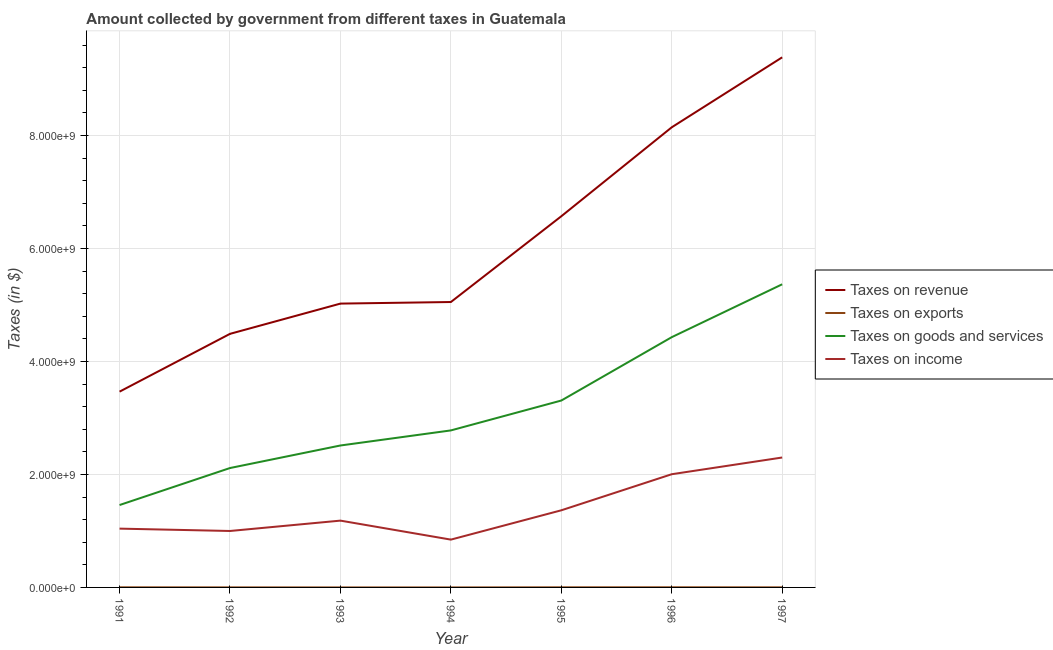Does the line corresponding to amount collected as tax on exports intersect with the line corresponding to amount collected as tax on revenue?
Make the answer very short. No. What is the amount collected as tax on goods in 1994?
Offer a terse response. 2.78e+09. Across all years, what is the maximum amount collected as tax on revenue?
Give a very brief answer. 9.38e+09. Across all years, what is the minimum amount collected as tax on revenue?
Give a very brief answer. 3.47e+09. What is the total amount collected as tax on revenue in the graph?
Keep it short and to the point. 4.21e+1. What is the difference between the amount collected as tax on income in 1991 and that in 1993?
Offer a very short reply. -1.42e+08. What is the difference between the amount collected as tax on income in 1997 and the amount collected as tax on exports in 1995?
Keep it short and to the point. 2.30e+09. What is the average amount collected as tax on revenue per year?
Provide a succinct answer. 6.02e+09. In the year 1997, what is the difference between the amount collected as tax on income and amount collected as tax on goods?
Your answer should be compact. -3.07e+09. In how many years, is the amount collected as tax on goods greater than 8000000000 $?
Offer a terse response. 0. What is the ratio of the amount collected as tax on income in 1993 to that in 1997?
Keep it short and to the point. 0.51. Is the amount collected as tax on goods in 1991 less than that in 1995?
Offer a very short reply. Yes. What is the difference between the highest and the second highest amount collected as tax on exports?
Your answer should be very brief. 6.90e+05. What is the difference between the highest and the lowest amount collected as tax on income?
Your answer should be very brief. 1.45e+09. Is the sum of the amount collected as tax on income in 1992 and 1997 greater than the maximum amount collected as tax on revenue across all years?
Offer a very short reply. No. Is the amount collected as tax on income strictly greater than the amount collected as tax on exports over the years?
Your answer should be very brief. Yes. Is the amount collected as tax on goods strictly less than the amount collected as tax on income over the years?
Make the answer very short. No. How many years are there in the graph?
Ensure brevity in your answer.  7. Are the values on the major ticks of Y-axis written in scientific E-notation?
Keep it short and to the point. Yes. Does the graph contain any zero values?
Provide a short and direct response. No. Does the graph contain grids?
Provide a succinct answer. Yes. How many legend labels are there?
Keep it short and to the point. 4. What is the title of the graph?
Offer a very short reply. Amount collected by government from different taxes in Guatemala. What is the label or title of the X-axis?
Provide a succinct answer. Year. What is the label or title of the Y-axis?
Keep it short and to the point. Taxes (in $). What is the Taxes (in $) in Taxes on revenue in 1991?
Offer a very short reply. 3.47e+09. What is the Taxes (in $) of Taxes on exports in 1991?
Your response must be concise. 1.92e+06. What is the Taxes (in $) in Taxes on goods and services in 1991?
Offer a terse response. 1.46e+09. What is the Taxes (in $) in Taxes on income in 1991?
Your answer should be compact. 1.04e+09. What is the Taxes (in $) of Taxes on revenue in 1992?
Your response must be concise. 4.49e+09. What is the Taxes (in $) of Taxes on exports in 1992?
Your answer should be very brief. 8.80e+05. What is the Taxes (in $) in Taxes on goods and services in 1992?
Provide a short and direct response. 2.11e+09. What is the Taxes (in $) in Taxes on income in 1992?
Your response must be concise. 9.99e+08. What is the Taxes (in $) of Taxes on revenue in 1993?
Offer a very short reply. 5.02e+09. What is the Taxes (in $) of Taxes on goods and services in 1993?
Your response must be concise. 2.51e+09. What is the Taxes (in $) in Taxes on income in 1993?
Your response must be concise. 1.18e+09. What is the Taxes (in $) in Taxes on revenue in 1994?
Ensure brevity in your answer.  5.05e+09. What is the Taxes (in $) of Taxes on goods and services in 1994?
Your answer should be compact. 2.78e+09. What is the Taxes (in $) of Taxes on income in 1994?
Offer a terse response. 8.46e+08. What is the Taxes (in $) in Taxes on revenue in 1995?
Provide a succinct answer. 6.57e+09. What is the Taxes (in $) in Taxes on exports in 1995?
Keep it short and to the point. 1.91e+06. What is the Taxes (in $) of Taxes on goods and services in 1995?
Keep it short and to the point. 3.31e+09. What is the Taxes (in $) in Taxes on income in 1995?
Offer a terse response. 1.37e+09. What is the Taxes (in $) in Taxes on revenue in 1996?
Keep it short and to the point. 8.14e+09. What is the Taxes (in $) of Taxes on exports in 1996?
Keep it short and to the point. 2.61e+06. What is the Taxes (in $) of Taxes on goods and services in 1996?
Your answer should be compact. 4.43e+09. What is the Taxes (in $) in Taxes on income in 1996?
Ensure brevity in your answer.  2.00e+09. What is the Taxes (in $) of Taxes on revenue in 1997?
Offer a terse response. 9.38e+09. What is the Taxes (in $) of Taxes on exports in 1997?
Offer a very short reply. 1.49e+06. What is the Taxes (in $) in Taxes on goods and services in 1997?
Ensure brevity in your answer.  5.37e+09. What is the Taxes (in $) in Taxes on income in 1997?
Ensure brevity in your answer.  2.30e+09. Across all years, what is the maximum Taxes (in $) of Taxes on revenue?
Your response must be concise. 9.38e+09. Across all years, what is the maximum Taxes (in $) in Taxes on exports?
Ensure brevity in your answer.  2.61e+06. Across all years, what is the maximum Taxes (in $) in Taxes on goods and services?
Provide a succinct answer. 5.37e+09. Across all years, what is the maximum Taxes (in $) in Taxes on income?
Ensure brevity in your answer.  2.30e+09. Across all years, what is the minimum Taxes (in $) of Taxes on revenue?
Offer a very short reply. 3.47e+09. Across all years, what is the minimum Taxes (in $) in Taxes on goods and services?
Ensure brevity in your answer.  1.46e+09. Across all years, what is the minimum Taxes (in $) of Taxes on income?
Provide a short and direct response. 8.46e+08. What is the total Taxes (in $) of Taxes on revenue in the graph?
Offer a very short reply. 4.21e+1. What is the total Taxes (in $) of Taxes on exports in the graph?
Your response must be concise. 8.83e+06. What is the total Taxes (in $) of Taxes on goods and services in the graph?
Your answer should be compact. 2.20e+1. What is the total Taxes (in $) of Taxes on income in the graph?
Offer a very short reply. 9.74e+09. What is the difference between the Taxes (in $) in Taxes on revenue in 1991 and that in 1992?
Offer a terse response. -1.02e+09. What is the difference between the Taxes (in $) in Taxes on exports in 1991 and that in 1992?
Your response must be concise. 1.04e+06. What is the difference between the Taxes (in $) in Taxes on goods and services in 1991 and that in 1992?
Offer a terse response. -6.55e+08. What is the difference between the Taxes (in $) of Taxes on income in 1991 and that in 1992?
Offer a very short reply. 4.18e+07. What is the difference between the Taxes (in $) of Taxes on revenue in 1991 and that in 1993?
Your answer should be very brief. -1.56e+09. What is the difference between the Taxes (in $) in Taxes on exports in 1991 and that in 1993?
Make the answer very short. 1.91e+06. What is the difference between the Taxes (in $) in Taxes on goods and services in 1991 and that in 1993?
Keep it short and to the point. -1.05e+09. What is the difference between the Taxes (in $) of Taxes on income in 1991 and that in 1993?
Make the answer very short. -1.42e+08. What is the difference between the Taxes (in $) of Taxes on revenue in 1991 and that in 1994?
Your answer should be compact. -1.59e+09. What is the difference between the Taxes (in $) in Taxes on exports in 1991 and that in 1994?
Provide a succinct answer. 1.91e+06. What is the difference between the Taxes (in $) of Taxes on goods and services in 1991 and that in 1994?
Keep it short and to the point. -1.32e+09. What is the difference between the Taxes (in $) of Taxes on income in 1991 and that in 1994?
Make the answer very short. 1.95e+08. What is the difference between the Taxes (in $) of Taxes on revenue in 1991 and that in 1995?
Your response must be concise. -3.10e+09. What is the difference between the Taxes (in $) in Taxes on goods and services in 1991 and that in 1995?
Your response must be concise. -1.85e+09. What is the difference between the Taxes (in $) of Taxes on income in 1991 and that in 1995?
Ensure brevity in your answer.  -3.24e+08. What is the difference between the Taxes (in $) in Taxes on revenue in 1991 and that in 1996?
Offer a terse response. -4.68e+09. What is the difference between the Taxes (in $) in Taxes on exports in 1991 and that in 1996?
Make the answer very short. -6.90e+05. What is the difference between the Taxes (in $) in Taxes on goods and services in 1991 and that in 1996?
Give a very brief answer. -2.97e+09. What is the difference between the Taxes (in $) of Taxes on income in 1991 and that in 1996?
Offer a very short reply. -9.63e+08. What is the difference between the Taxes (in $) in Taxes on revenue in 1991 and that in 1997?
Offer a terse response. -5.92e+09. What is the difference between the Taxes (in $) in Taxes on exports in 1991 and that in 1997?
Your answer should be compact. 4.30e+05. What is the difference between the Taxes (in $) of Taxes on goods and services in 1991 and that in 1997?
Offer a terse response. -3.91e+09. What is the difference between the Taxes (in $) in Taxes on income in 1991 and that in 1997?
Provide a succinct answer. -1.26e+09. What is the difference between the Taxes (in $) in Taxes on revenue in 1992 and that in 1993?
Your answer should be compact. -5.35e+08. What is the difference between the Taxes (in $) of Taxes on exports in 1992 and that in 1993?
Your response must be concise. 8.70e+05. What is the difference between the Taxes (in $) in Taxes on goods and services in 1992 and that in 1993?
Make the answer very short. -3.99e+08. What is the difference between the Taxes (in $) of Taxes on income in 1992 and that in 1993?
Keep it short and to the point. -1.83e+08. What is the difference between the Taxes (in $) of Taxes on revenue in 1992 and that in 1994?
Your answer should be very brief. -5.63e+08. What is the difference between the Taxes (in $) of Taxes on exports in 1992 and that in 1994?
Ensure brevity in your answer.  8.70e+05. What is the difference between the Taxes (in $) of Taxes on goods and services in 1992 and that in 1994?
Provide a short and direct response. -6.66e+08. What is the difference between the Taxes (in $) in Taxes on income in 1992 and that in 1994?
Offer a terse response. 1.53e+08. What is the difference between the Taxes (in $) in Taxes on revenue in 1992 and that in 1995?
Your answer should be compact. -2.08e+09. What is the difference between the Taxes (in $) of Taxes on exports in 1992 and that in 1995?
Your answer should be compact. -1.03e+06. What is the difference between the Taxes (in $) of Taxes on goods and services in 1992 and that in 1995?
Your answer should be very brief. -1.19e+09. What is the difference between the Taxes (in $) in Taxes on income in 1992 and that in 1995?
Your answer should be very brief. -3.66e+08. What is the difference between the Taxes (in $) of Taxes on revenue in 1992 and that in 1996?
Your answer should be very brief. -3.66e+09. What is the difference between the Taxes (in $) in Taxes on exports in 1992 and that in 1996?
Provide a succinct answer. -1.73e+06. What is the difference between the Taxes (in $) of Taxes on goods and services in 1992 and that in 1996?
Offer a terse response. -2.32e+09. What is the difference between the Taxes (in $) of Taxes on income in 1992 and that in 1996?
Provide a succinct answer. -1.00e+09. What is the difference between the Taxes (in $) of Taxes on revenue in 1992 and that in 1997?
Your response must be concise. -4.89e+09. What is the difference between the Taxes (in $) of Taxes on exports in 1992 and that in 1997?
Keep it short and to the point. -6.10e+05. What is the difference between the Taxes (in $) in Taxes on goods and services in 1992 and that in 1997?
Provide a succinct answer. -3.25e+09. What is the difference between the Taxes (in $) in Taxes on income in 1992 and that in 1997?
Make the answer very short. -1.30e+09. What is the difference between the Taxes (in $) in Taxes on revenue in 1993 and that in 1994?
Provide a short and direct response. -2.78e+07. What is the difference between the Taxes (in $) in Taxes on goods and services in 1993 and that in 1994?
Your answer should be compact. -2.67e+08. What is the difference between the Taxes (in $) in Taxes on income in 1993 and that in 1994?
Give a very brief answer. 3.36e+08. What is the difference between the Taxes (in $) of Taxes on revenue in 1993 and that in 1995?
Ensure brevity in your answer.  -1.55e+09. What is the difference between the Taxes (in $) in Taxes on exports in 1993 and that in 1995?
Provide a short and direct response. -1.90e+06. What is the difference between the Taxes (in $) in Taxes on goods and services in 1993 and that in 1995?
Make the answer very short. -7.96e+08. What is the difference between the Taxes (in $) in Taxes on income in 1993 and that in 1995?
Your answer should be very brief. -1.83e+08. What is the difference between the Taxes (in $) in Taxes on revenue in 1993 and that in 1996?
Your response must be concise. -3.12e+09. What is the difference between the Taxes (in $) in Taxes on exports in 1993 and that in 1996?
Your answer should be compact. -2.60e+06. What is the difference between the Taxes (in $) of Taxes on goods and services in 1993 and that in 1996?
Provide a succinct answer. -1.92e+09. What is the difference between the Taxes (in $) of Taxes on income in 1993 and that in 1996?
Provide a short and direct response. -8.21e+08. What is the difference between the Taxes (in $) of Taxes on revenue in 1993 and that in 1997?
Provide a short and direct response. -4.36e+09. What is the difference between the Taxes (in $) of Taxes on exports in 1993 and that in 1997?
Keep it short and to the point. -1.48e+06. What is the difference between the Taxes (in $) of Taxes on goods and services in 1993 and that in 1997?
Provide a succinct answer. -2.85e+09. What is the difference between the Taxes (in $) of Taxes on income in 1993 and that in 1997?
Keep it short and to the point. -1.12e+09. What is the difference between the Taxes (in $) in Taxes on revenue in 1994 and that in 1995?
Give a very brief answer. -1.52e+09. What is the difference between the Taxes (in $) of Taxes on exports in 1994 and that in 1995?
Provide a short and direct response. -1.90e+06. What is the difference between the Taxes (in $) of Taxes on goods and services in 1994 and that in 1995?
Your answer should be compact. -5.29e+08. What is the difference between the Taxes (in $) of Taxes on income in 1994 and that in 1995?
Your answer should be very brief. -5.19e+08. What is the difference between the Taxes (in $) in Taxes on revenue in 1994 and that in 1996?
Make the answer very short. -3.09e+09. What is the difference between the Taxes (in $) in Taxes on exports in 1994 and that in 1996?
Provide a short and direct response. -2.60e+06. What is the difference between the Taxes (in $) in Taxes on goods and services in 1994 and that in 1996?
Your answer should be very brief. -1.65e+09. What is the difference between the Taxes (in $) in Taxes on income in 1994 and that in 1996?
Provide a short and direct response. -1.16e+09. What is the difference between the Taxes (in $) of Taxes on revenue in 1994 and that in 1997?
Offer a very short reply. -4.33e+09. What is the difference between the Taxes (in $) of Taxes on exports in 1994 and that in 1997?
Your answer should be compact. -1.48e+06. What is the difference between the Taxes (in $) of Taxes on goods and services in 1994 and that in 1997?
Offer a very short reply. -2.59e+09. What is the difference between the Taxes (in $) in Taxes on income in 1994 and that in 1997?
Keep it short and to the point. -1.45e+09. What is the difference between the Taxes (in $) of Taxes on revenue in 1995 and that in 1996?
Ensure brevity in your answer.  -1.57e+09. What is the difference between the Taxes (in $) in Taxes on exports in 1995 and that in 1996?
Ensure brevity in your answer.  -7.00e+05. What is the difference between the Taxes (in $) of Taxes on goods and services in 1995 and that in 1996?
Offer a very short reply. -1.12e+09. What is the difference between the Taxes (in $) in Taxes on income in 1995 and that in 1996?
Your answer should be very brief. -6.39e+08. What is the difference between the Taxes (in $) of Taxes on revenue in 1995 and that in 1997?
Your response must be concise. -2.81e+09. What is the difference between the Taxes (in $) of Taxes on exports in 1995 and that in 1997?
Give a very brief answer. 4.20e+05. What is the difference between the Taxes (in $) of Taxes on goods and services in 1995 and that in 1997?
Your response must be concise. -2.06e+09. What is the difference between the Taxes (in $) of Taxes on income in 1995 and that in 1997?
Offer a terse response. -9.34e+08. What is the difference between the Taxes (in $) in Taxes on revenue in 1996 and that in 1997?
Provide a succinct answer. -1.24e+09. What is the difference between the Taxes (in $) of Taxes on exports in 1996 and that in 1997?
Offer a very short reply. 1.12e+06. What is the difference between the Taxes (in $) in Taxes on goods and services in 1996 and that in 1997?
Offer a very short reply. -9.36e+08. What is the difference between the Taxes (in $) of Taxes on income in 1996 and that in 1997?
Your answer should be compact. -2.96e+08. What is the difference between the Taxes (in $) of Taxes on revenue in 1991 and the Taxes (in $) of Taxes on exports in 1992?
Keep it short and to the point. 3.46e+09. What is the difference between the Taxes (in $) of Taxes on revenue in 1991 and the Taxes (in $) of Taxes on goods and services in 1992?
Offer a very short reply. 1.35e+09. What is the difference between the Taxes (in $) of Taxes on revenue in 1991 and the Taxes (in $) of Taxes on income in 1992?
Provide a succinct answer. 2.47e+09. What is the difference between the Taxes (in $) of Taxes on exports in 1991 and the Taxes (in $) of Taxes on goods and services in 1992?
Ensure brevity in your answer.  -2.11e+09. What is the difference between the Taxes (in $) of Taxes on exports in 1991 and the Taxes (in $) of Taxes on income in 1992?
Your response must be concise. -9.97e+08. What is the difference between the Taxes (in $) of Taxes on goods and services in 1991 and the Taxes (in $) of Taxes on income in 1992?
Keep it short and to the point. 4.59e+08. What is the difference between the Taxes (in $) in Taxes on revenue in 1991 and the Taxes (in $) in Taxes on exports in 1993?
Keep it short and to the point. 3.47e+09. What is the difference between the Taxes (in $) in Taxes on revenue in 1991 and the Taxes (in $) in Taxes on goods and services in 1993?
Keep it short and to the point. 9.53e+08. What is the difference between the Taxes (in $) in Taxes on revenue in 1991 and the Taxes (in $) in Taxes on income in 1993?
Your response must be concise. 2.28e+09. What is the difference between the Taxes (in $) of Taxes on exports in 1991 and the Taxes (in $) of Taxes on goods and services in 1993?
Your answer should be compact. -2.51e+09. What is the difference between the Taxes (in $) in Taxes on exports in 1991 and the Taxes (in $) in Taxes on income in 1993?
Offer a very short reply. -1.18e+09. What is the difference between the Taxes (in $) in Taxes on goods and services in 1991 and the Taxes (in $) in Taxes on income in 1993?
Your answer should be very brief. 2.76e+08. What is the difference between the Taxes (in $) of Taxes on revenue in 1991 and the Taxes (in $) of Taxes on exports in 1994?
Your answer should be compact. 3.47e+09. What is the difference between the Taxes (in $) of Taxes on revenue in 1991 and the Taxes (in $) of Taxes on goods and services in 1994?
Your answer should be very brief. 6.86e+08. What is the difference between the Taxes (in $) of Taxes on revenue in 1991 and the Taxes (in $) of Taxes on income in 1994?
Offer a terse response. 2.62e+09. What is the difference between the Taxes (in $) in Taxes on exports in 1991 and the Taxes (in $) in Taxes on goods and services in 1994?
Provide a succinct answer. -2.78e+09. What is the difference between the Taxes (in $) of Taxes on exports in 1991 and the Taxes (in $) of Taxes on income in 1994?
Keep it short and to the point. -8.44e+08. What is the difference between the Taxes (in $) in Taxes on goods and services in 1991 and the Taxes (in $) in Taxes on income in 1994?
Your answer should be compact. 6.12e+08. What is the difference between the Taxes (in $) of Taxes on revenue in 1991 and the Taxes (in $) of Taxes on exports in 1995?
Provide a succinct answer. 3.46e+09. What is the difference between the Taxes (in $) of Taxes on revenue in 1991 and the Taxes (in $) of Taxes on goods and services in 1995?
Keep it short and to the point. 1.57e+08. What is the difference between the Taxes (in $) of Taxes on revenue in 1991 and the Taxes (in $) of Taxes on income in 1995?
Your response must be concise. 2.10e+09. What is the difference between the Taxes (in $) in Taxes on exports in 1991 and the Taxes (in $) in Taxes on goods and services in 1995?
Give a very brief answer. -3.31e+09. What is the difference between the Taxes (in $) of Taxes on exports in 1991 and the Taxes (in $) of Taxes on income in 1995?
Your answer should be very brief. -1.36e+09. What is the difference between the Taxes (in $) of Taxes on goods and services in 1991 and the Taxes (in $) of Taxes on income in 1995?
Ensure brevity in your answer.  9.32e+07. What is the difference between the Taxes (in $) in Taxes on revenue in 1991 and the Taxes (in $) in Taxes on exports in 1996?
Provide a short and direct response. 3.46e+09. What is the difference between the Taxes (in $) of Taxes on revenue in 1991 and the Taxes (in $) of Taxes on goods and services in 1996?
Your answer should be compact. -9.64e+08. What is the difference between the Taxes (in $) of Taxes on revenue in 1991 and the Taxes (in $) of Taxes on income in 1996?
Offer a very short reply. 1.46e+09. What is the difference between the Taxes (in $) in Taxes on exports in 1991 and the Taxes (in $) in Taxes on goods and services in 1996?
Ensure brevity in your answer.  -4.43e+09. What is the difference between the Taxes (in $) of Taxes on exports in 1991 and the Taxes (in $) of Taxes on income in 1996?
Ensure brevity in your answer.  -2.00e+09. What is the difference between the Taxes (in $) of Taxes on goods and services in 1991 and the Taxes (in $) of Taxes on income in 1996?
Make the answer very short. -5.45e+08. What is the difference between the Taxes (in $) of Taxes on revenue in 1991 and the Taxes (in $) of Taxes on exports in 1997?
Offer a very short reply. 3.46e+09. What is the difference between the Taxes (in $) of Taxes on revenue in 1991 and the Taxes (in $) of Taxes on goods and services in 1997?
Provide a succinct answer. -1.90e+09. What is the difference between the Taxes (in $) of Taxes on revenue in 1991 and the Taxes (in $) of Taxes on income in 1997?
Provide a short and direct response. 1.17e+09. What is the difference between the Taxes (in $) of Taxes on exports in 1991 and the Taxes (in $) of Taxes on goods and services in 1997?
Ensure brevity in your answer.  -5.36e+09. What is the difference between the Taxes (in $) of Taxes on exports in 1991 and the Taxes (in $) of Taxes on income in 1997?
Offer a very short reply. -2.30e+09. What is the difference between the Taxes (in $) in Taxes on goods and services in 1991 and the Taxes (in $) in Taxes on income in 1997?
Ensure brevity in your answer.  -8.41e+08. What is the difference between the Taxes (in $) of Taxes on revenue in 1992 and the Taxes (in $) of Taxes on exports in 1993?
Offer a very short reply. 4.49e+09. What is the difference between the Taxes (in $) in Taxes on revenue in 1992 and the Taxes (in $) in Taxes on goods and services in 1993?
Offer a very short reply. 1.98e+09. What is the difference between the Taxes (in $) in Taxes on revenue in 1992 and the Taxes (in $) in Taxes on income in 1993?
Provide a succinct answer. 3.31e+09. What is the difference between the Taxes (in $) in Taxes on exports in 1992 and the Taxes (in $) in Taxes on goods and services in 1993?
Keep it short and to the point. -2.51e+09. What is the difference between the Taxes (in $) of Taxes on exports in 1992 and the Taxes (in $) of Taxes on income in 1993?
Make the answer very short. -1.18e+09. What is the difference between the Taxes (in $) of Taxes on goods and services in 1992 and the Taxes (in $) of Taxes on income in 1993?
Give a very brief answer. 9.31e+08. What is the difference between the Taxes (in $) of Taxes on revenue in 1992 and the Taxes (in $) of Taxes on exports in 1994?
Ensure brevity in your answer.  4.49e+09. What is the difference between the Taxes (in $) of Taxes on revenue in 1992 and the Taxes (in $) of Taxes on goods and services in 1994?
Give a very brief answer. 1.71e+09. What is the difference between the Taxes (in $) of Taxes on revenue in 1992 and the Taxes (in $) of Taxes on income in 1994?
Your answer should be very brief. 3.64e+09. What is the difference between the Taxes (in $) in Taxes on exports in 1992 and the Taxes (in $) in Taxes on goods and services in 1994?
Keep it short and to the point. -2.78e+09. What is the difference between the Taxes (in $) of Taxes on exports in 1992 and the Taxes (in $) of Taxes on income in 1994?
Provide a succinct answer. -8.45e+08. What is the difference between the Taxes (in $) of Taxes on goods and services in 1992 and the Taxes (in $) of Taxes on income in 1994?
Offer a terse response. 1.27e+09. What is the difference between the Taxes (in $) of Taxes on revenue in 1992 and the Taxes (in $) of Taxes on exports in 1995?
Your answer should be compact. 4.49e+09. What is the difference between the Taxes (in $) of Taxes on revenue in 1992 and the Taxes (in $) of Taxes on goods and services in 1995?
Keep it short and to the point. 1.18e+09. What is the difference between the Taxes (in $) of Taxes on revenue in 1992 and the Taxes (in $) of Taxes on income in 1995?
Your answer should be compact. 3.12e+09. What is the difference between the Taxes (in $) in Taxes on exports in 1992 and the Taxes (in $) in Taxes on goods and services in 1995?
Give a very brief answer. -3.31e+09. What is the difference between the Taxes (in $) in Taxes on exports in 1992 and the Taxes (in $) in Taxes on income in 1995?
Offer a very short reply. -1.36e+09. What is the difference between the Taxes (in $) in Taxes on goods and services in 1992 and the Taxes (in $) in Taxes on income in 1995?
Provide a short and direct response. 7.48e+08. What is the difference between the Taxes (in $) in Taxes on revenue in 1992 and the Taxes (in $) in Taxes on exports in 1996?
Provide a succinct answer. 4.49e+09. What is the difference between the Taxes (in $) in Taxes on revenue in 1992 and the Taxes (in $) in Taxes on goods and services in 1996?
Provide a succinct answer. 5.88e+07. What is the difference between the Taxes (in $) of Taxes on revenue in 1992 and the Taxes (in $) of Taxes on income in 1996?
Offer a terse response. 2.48e+09. What is the difference between the Taxes (in $) in Taxes on exports in 1992 and the Taxes (in $) in Taxes on goods and services in 1996?
Provide a short and direct response. -4.43e+09. What is the difference between the Taxes (in $) of Taxes on exports in 1992 and the Taxes (in $) of Taxes on income in 1996?
Make the answer very short. -2.00e+09. What is the difference between the Taxes (in $) in Taxes on goods and services in 1992 and the Taxes (in $) in Taxes on income in 1996?
Provide a short and direct response. 1.10e+08. What is the difference between the Taxes (in $) of Taxes on revenue in 1992 and the Taxes (in $) of Taxes on exports in 1997?
Offer a very short reply. 4.49e+09. What is the difference between the Taxes (in $) of Taxes on revenue in 1992 and the Taxes (in $) of Taxes on goods and services in 1997?
Keep it short and to the point. -8.77e+08. What is the difference between the Taxes (in $) of Taxes on revenue in 1992 and the Taxes (in $) of Taxes on income in 1997?
Offer a terse response. 2.19e+09. What is the difference between the Taxes (in $) of Taxes on exports in 1992 and the Taxes (in $) of Taxes on goods and services in 1997?
Offer a terse response. -5.36e+09. What is the difference between the Taxes (in $) in Taxes on exports in 1992 and the Taxes (in $) in Taxes on income in 1997?
Your answer should be compact. -2.30e+09. What is the difference between the Taxes (in $) in Taxes on goods and services in 1992 and the Taxes (in $) in Taxes on income in 1997?
Offer a terse response. -1.86e+08. What is the difference between the Taxes (in $) in Taxes on revenue in 1993 and the Taxes (in $) in Taxes on exports in 1994?
Your answer should be compact. 5.02e+09. What is the difference between the Taxes (in $) in Taxes on revenue in 1993 and the Taxes (in $) in Taxes on goods and services in 1994?
Your response must be concise. 2.24e+09. What is the difference between the Taxes (in $) of Taxes on revenue in 1993 and the Taxes (in $) of Taxes on income in 1994?
Keep it short and to the point. 4.18e+09. What is the difference between the Taxes (in $) in Taxes on exports in 1993 and the Taxes (in $) in Taxes on goods and services in 1994?
Make the answer very short. -2.78e+09. What is the difference between the Taxes (in $) of Taxes on exports in 1993 and the Taxes (in $) of Taxes on income in 1994?
Provide a short and direct response. -8.46e+08. What is the difference between the Taxes (in $) of Taxes on goods and services in 1993 and the Taxes (in $) of Taxes on income in 1994?
Offer a very short reply. 1.67e+09. What is the difference between the Taxes (in $) of Taxes on revenue in 1993 and the Taxes (in $) of Taxes on exports in 1995?
Offer a terse response. 5.02e+09. What is the difference between the Taxes (in $) of Taxes on revenue in 1993 and the Taxes (in $) of Taxes on goods and services in 1995?
Offer a terse response. 1.72e+09. What is the difference between the Taxes (in $) of Taxes on revenue in 1993 and the Taxes (in $) of Taxes on income in 1995?
Give a very brief answer. 3.66e+09. What is the difference between the Taxes (in $) of Taxes on exports in 1993 and the Taxes (in $) of Taxes on goods and services in 1995?
Provide a succinct answer. -3.31e+09. What is the difference between the Taxes (in $) in Taxes on exports in 1993 and the Taxes (in $) in Taxes on income in 1995?
Offer a very short reply. -1.37e+09. What is the difference between the Taxes (in $) of Taxes on goods and services in 1993 and the Taxes (in $) of Taxes on income in 1995?
Ensure brevity in your answer.  1.15e+09. What is the difference between the Taxes (in $) of Taxes on revenue in 1993 and the Taxes (in $) of Taxes on exports in 1996?
Provide a succinct answer. 5.02e+09. What is the difference between the Taxes (in $) in Taxes on revenue in 1993 and the Taxes (in $) in Taxes on goods and services in 1996?
Provide a succinct answer. 5.94e+08. What is the difference between the Taxes (in $) in Taxes on revenue in 1993 and the Taxes (in $) in Taxes on income in 1996?
Provide a succinct answer. 3.02e+09. What is the difference between the Taxes (in $) in Taxes on exports in 1993 and the Taxes (in $) in Taxes on goods and services in 1996?
Your answer should be compact. -4.43e+09. What is the difference between the Taxes (in $) in Taxes on exports in 1993 and the Taxes (in $) in Taxes on income in 1996?
Make the answer very short. -2.00e+09. What is the difference between the Taxes (in $) of Taxes on goods and services in 1993 and the Taxes (in $) of Taxes on income in 1996?
Ensure brevity in your answer.  5.09e+08. What is the difference between the Taxes (in $) in Taxes on revenue in 1993 and the Taxes (in $) in Taxes on exports in 1997?
Provide a succinct answer. 5.02e+09. What is the difference between the Taxes (in $) in Taxes on revenue in 1993 and the Taxes (in $) in Taxes on goods and services in 1997?
Provide a succinct answer. -3.42e+08. What is the difference between the Taxes (in $) of Taxes on revenue in 1993 and the Taxes (in $) of Taxes on income in 1997?
Offer a terse response. 2.72e+09. What is the difference between the Taxes (in $) in Taxes on exports in 1993 and the Taxes (in $) in Taxes on goods and services in 1997?
Make the answer very short. -5.37e+09. What is the difference between the Taxes (in $) of Taxes on exports in 1993 and the Taxes (in $) of Taxes on income in 1997?
Offer a terse response. -2.30e+09. What is the difference between the Taxes (in $) of Taxes on goods and services in 1993 and the Taxes (in $) of Taxes on income in 1997?
Ensure brevity in your answer.  2.13e+08. What is the difference between the Taxes (in $) in Taxes on revenue in 1994 and the Taxes (in $) in Taxes on exports in 1995?
Offer a very short reply. 5.05e+09. What is the difference between the Taxes (in $) in Taxes on revenue in 1994 and the Taxes (in $) in Taxes on goods and services in 1995?
Your response must be concise. 1.74e+09. What is the difference between the Taxes (in $) in Taxes on revenue in 1994 and the Taxes (in $) in Taxes on income in 1995?
Your answer should be very brief. 3.69e+09. What is the difference between the Taxes (in $) of Taxes on exports in 1994 and the Taxes (in $) of Taxes on goods and services in 1995?
Ensure brevity in your answer.  -3.31e+09. What is the difference between the Taxes (in $) in Taxes on exports in 1994 and the Taxes (in $) in Taxes on income in 1995?
Ensure brevity in your answer.  -1.37e+09. What is the difference between the Taxes (in $) of Taxes on goods and services in 1994 and the Taxes (in $) of Taxes on income in 1995?
Your answer should be very brief. 1.41e+09. What is the difference between the Taxes (in $) of Taxes on revenue in 1994 and the Taxes (in $) of Taxes on exports in 1996?
Your answer should be compact. 5.05e+09. What is the difference between the Taxes (in $) of Taxes on revenue in 1994 and the Taxes (in $) of Taxes on goods and services in 1996?
Provide a succinct answer. 6.22e+08. What is the difference between the Taxes (in $) of Taxes on revenue in 1994 and the Taxes (in $) of Taxes on income in 1996?
Provide a short and direct response. 3.05e+09. What is the difference between the Taxes (in $) of Taxes on exports in 1994 and the Taxes (in $) of Taxes on goods and services in 1996?
Provide a succinct answer. -4.43e+09. What is the difference between the Taxes (in $) of Taxes on exports in 1994 and the Taxes (in $) of Taxes on income in 1996?
Make the answer very short. -2.00e+09. What is the difference between the Taxes (in $) of Taxes on goods and services in 1994 and the Taxes (in $) of Taxes on income in 1996?
Give a very brief answer. 7.75e+08. What is the difference between the Taxes (in $) in Taxes on revenue in 1994 and the Taxes (in $) in Taxes on exports in 1997?
Ensure brevity in your answer.  5.05e+09. What is the difference between the Taxes (in $) in Taxes on revenue in 1994 and the Taxes (in $) in Taxes on goods and services in 1997?
Your answer should be very brief. -3.14e+08. What is the difference between the Taxes (in $) of Taxes on revenue in 1994 and the Taxes (in $) of Taxes on income in 1997?
Offer a very short reply. 2.75e+09. What is the difference between the Taxes (in $) of Taxes on exports in 1994 and the Taxes (in $) of Taxes on goods and services in 1997?
Offer a very short reply. -5.37e+09. What is the difference between the Taxes (in $) in Taxes on exports in 1994 and the Taxes (in $) in Taxes on income in 1997?
Offer a terse response. -2.30e+09. What is the difference between the Taxes (in $) in Taxes on goods and services in 1994 and the Taxes (in $) in Taxes on income in 1997?
Your answer should be compact. 4.79e+08. What is the difference between the Taxes (in $) of Taxes on revenue in 1995 and the Taxes (in $) of Taxes on exports in 1996?
Your response must be concise. 6.57e+09. What is the difference between the Taxes (in $) of Taxes on revenue in 1995 and the Taxes (in $) of Taxes on goods and services in 1996?
Provide a succinct answer. 2.14e+09. What is the difference between the Taxes (in $) of Taxes on revenue in 1995 and the Taxes (in $) of Taxes on income in 1996?
Offer a very short reply. 4.57e+09. What is the difference between the Taxes (in $) of Taxes on exports in 1995 and the Taxes (in $) of Taxes on goods and services in 1996?
Your answer should be very brief. -4.43e+09. What is the difference between the Taxes (in $) in Taxes on exports in 1995 and the Taxes (in $) in Taxes on income in 1996?
Your response must be concise. -2.00e+09. What is the difference between the Taxes (in $) of Taxes on goods and services in 1995 and the Taxes (in $) of Taxes on income in 1996?
Your answer should be compact. 1.30e+09. What is the difference between the Taxes (in $) in Taxes on revenue in 1995 and the Taxes (in $) in Taxes on exports in 1997?
Offer a very short reply. 6.57e+09. What is the difference between the Taxes (in $) of Taxes on revenue in 1995 and the Taxes (in $) of Taxes on goods and services in 1997?
Your answer should be very brief. 1.20e+09. What is the difference between the Taxes (in $) of Taxes on revenue in 1995 and the Taxes (in $) of Taxes on income in 1997?
Provide a succinct answer. 4.27e+09. What is the difference between the Taxes (in $) in Taxes on exports in 1995 and the Taxes (in $) in Taxes on goods and services in 1997?
Give a very brief answer. -5.36e+09. What is the difference between the Taxes (in $) in Taxes on exports in 1995 and the Taxes (in $) in Taxes on income in 1997?
Your answer should be compact. -2.30e+09. What is the difference between the Taxes (in $) of Taxes on goods and services in 1995 and the Taxes (in $) of Taxes on income in 1997?
Make the answer very short. 1.01e+09. What is the difference between the Taxes (in $) in Taxes on revenue in 1996 and the Taxes (in $) in Taxes on exports in 1997?
Offer a terse response. 8.14e+09. What is the difference between the Taxes (in $) of Taxes on revenue in 1996 and the Taxes (in $) of Taxes on goods and services in 1997?
Provide a short and direct response. 2.78e+09. What is the difference between the Taxes (in $) in Taxes on revenue in 1996 and the Taxes (in $) in Taxes on income in 1997?
Ensure brevity in your answer.  5.84e+09. What is the difference between the Taxes (in $) in Taxes on exports in 1996 and the Taxes (in $) in Taxes on goods and services in 1997?
Your response must be concise. -5.36e+09. What is the difference between the Taxes (in $) of Taxes on exports in 1996 and the Taxes (in $) of Taxes on income in 1997?
Offer a very short reply. -2.30e+09. What is the difference between the Taxes (in $) in Taxes on goods and services in 1996 and the Taxes (in $) in Taxes on income in 1997?
Ensure brevity in your answer.  2.13e+09. What is the average Taxes (in $) in Taxes on revenue per year?
Keep it short and to the point. 6.02e+09. What is the average Taxes (in $) of Taxes on exports per year?
Your answer should be very brief. 1.26e+06. What is the average Taxes (in $) in Taxes on goods and services per year?
Offer a terse response. 3.14e+09. What is the average Taxes (in $) of Taxes on income per year?
Your answer should be very brief. 1.39e+09. In the year 1991, what is the difference between the Taxes (in $) of Taxes on revenue and Taxes (in $) of Taxes on exports?
Keep it short and to the point. 3.46e+09. In the year 1991, what is the difference between the Taxes (in $) of Taxes on revenue and Taxes (in $) of Taxes on goods and services?
Provide a short and direct response. 2.01e+09. In the year 1991, what is the difference between the Taxes (in $) in Taxes on revenue and Taxes (in $) in Taxes on income?
Keep it short and to the point. 2.42e+09. In the year 1991, what is the difference between the Taxes (in $) of Taxes on exports and Taxes (in $) of Taxes on goods and services?
Make the answer very short. -1.46e+09. In the year 1991, what is the difference between the Taxes (in $) of Taxes on exports and Taxes (in $) of Taxes on income?
Provide a succinct answer. -1.04e+09. In the year 1991, what is the difference between the Taxes (in $) of Taxes on goods and services and Taxes (in $) of Taxes on income?
Offer a terse response. 4.17e+08. In the year 1992, what is the difference between the Taxes (in $) in Taxes on revenue and Taxes (in $) in Taxes on exports?
Your answer should be very brief. 4.49e+09. In the year 1992, what is the difference between the Taxes (in $) of Taxes on revenue and Taxes (in $) of Taxes on goods and services?
Make the answer very short. 2.38e+09. In the year 1992, what is the difference between the Taxes (in $) in Taxes on revenue and Taxes (in $) in Taxes on income?
Your answer should be very brief. 3.49e+09. In the year 1992, what is the difference between the Taxes (in $) in Taxes on exports and Taxes (in $) in Taxes on goods and services?
Keep it short and to the point. -2.11e+09. In the year 1992, what is the difference between the Taxes (in $) in Taxes on exports and Taxes (in $) in Taxes on income?
Provide a succinct answer. -9.98e+08. In the year 1992, what is the difference between the Taxes (in $) in Taxes on goods and services and Taxes (in $) in Taxes on income?
Your answer should be very brief. 1.11e+09. In the year 1993, what is the difference between the Taxes (in $) of Taxes on revenue and Taxes (in $) of Taxes on exports?
Your response must be concise. 5.02e+09. In the year 1993, what is the difference between the Taxes (in $) of Taxes on revenue and Taxes (in $) of Taxes on goods and services?
Keep it short and to the point. 2.51e+09. In the year 1993, what is the difference between the Taxes (in $) in Taxes on revenue and Taxes (in $) in Taxes on income?
Make the answer very short. 3.84e+09. In the year 1993, what is the difference between the Taxes (in $) of Taxes on exports and Taxes (in $) of Taxes on goods and services?
Offer a very short reply. -2.51e+09. In the year 1993, what is the difference between the Taxes (in $) of Taxes on exports and Taxes (in $) of Taxes on income?
Give a very brief answer. -1.18e+09. In the year 1993, what is the difference between the Taxes (in $) of Taxes on goods and services and Taxes (in $) of Taxes on income?
Ensure brevity in your answer.  1.33e+09. In the year 1994, what is the difference between the Taxes (in $) in Taxes on revenue and Taxes (in $) in Taxes on exports?
Provide a succinct answer. 5.05e+09. In the year 1994, what is the difference between the Taxes (in $) of Taxes on revenue and Taxes (in $) of Taxes on goods and services?
Your answer should be compact. 2.27e+09. In the year 1994, what is the difference between the Taxes (in $) of Taxes on revenue and Taxes (in $) of Taxes on income?
Keep it short and to the point. 4.21e+09. In the year 1994, what is the difference between the Taxes (in $) of Taxes on exports and Taxes (in $) of Taxes on goods and services?
Provide a succinct answer. -2.78e+09. In the year 1994, what is the difference between the Taxes (in $) of Taxes on exports and Taxes (in $) of Taxes on income?
Offer a very short reply. -8.46e+08. In the year 1994, what is the difference between the Taxes (in $) of Taxes on goods and services and Taxes (in $) of Taxes on income?
Your answer should be very brief. 1.93e+09. In the year 1995, what is the difference between the Taxes (in $) of Taxes on revenue and Taxes (in $) of Taxes on exports?
Keep it short and to the point. 6.57e+09. In the year 1995, what is the difference between the Taxes (in $) in Taxes on revenue and Taxes (in $) in Taxes on goods and services?
Ensure brevity in your answer.  3.26e+09. In the year 1995, what is the difference between the Taxes (in $) of Taxes on revenue and Taxes (in $) of Taxes on income?
Provide a succinct answer. 5.20e+09. In the year 1995, what is the difference between the Taxes (in $) of Taxes on exports and Taxes (in $) of Taxes on goods and services?
Offer a terse response. -3.31e+09. In the year 1995, what is the difference between the Taxes (in $) in Taxes on exports and Taxes (in $) in Taxes on income?
Offer a very short reply. -1.36e+09. In the year 1995, what is the difference between the Taxes (in $) of Taxes on goods and services and Taxes (in $) of Taxes on income?
Your response must be concise. 1.94e+09. In the year 1996, what is the difference between the Taxes (in $) in Taxes on revenue and Taxes (in $) in Taxes on exports?
Provide a succinct answer. 8.14e+09. In the year 1996, what is the difference between the Taxes (in $) of Taxes on revenue and Taxes (in $) of Taxes on goods and services?
Your answer should be compact. 3.71e+09. In the year 1996, what is the difference between the Taxes (in $) in Taxes on revenue and Taxes (in $) in Taxes on income?
Your response must be concise. 6.14e+09. In the year 1996, what is the difference between the Taxes (in $) in Taxes on exports and Taxes (in $) in Taxes on goods and services?
Give a very brief answer. -4.43e+09. In the year 1996, what is the difference between the Taxes (in $) of Taxes on exports and Taxes (in $) of Taxes on income?
Keep it short and to the point. -2.00e+09. In the year 1996, what is the difference between the Taxes (in $) of Taxes on goods and services and Taxes (in $) of Taxes on income?
Your answer should be very brief. 2.43e+09. In the year 1997, what is the difference between the Taxes (in $) of Taxes on revenue and Taxes (in $) of Taxes on exports?
Keep it short and to the point. 9.38e+09. In the year 1997, what is the difference between the Taxes (in $) in Taxes on revenue and Taxes (in $) in Taxes on goods and services?
Your answer should be very brief. 4.02e+09. In the year 1997, what is the difference between the Taxes (in $) in Taxes on revenue and Taxes (in $) in Taxes on income?
Offer a terse response. 7.08e+09. In the year 1997, what is the difference between the Taxes (in $) in Taxes on exports and Taxes (in $) in Taxes on goods and services?
Make the answer very short. -5.36e+09. In the year 1997, what is the difference between the Taxes (in $) of Taxes on exports and Taxes (in $) of Taxes on income?
Offer a very short reply. -2.30e+09. In the year 1997, what is the difference between the Taxes (in $) in Taxes on goods and services and Taxes (in $) in Taxes on income?
Ensure brevity in your answer.  3.07e+09. What is the ratio of the Taxes (in $) of Taxes on revenue in 1991 to that in 1992?
Offer a terse response. 0.77. What is the ratio of the Taxes (in $) in Taxes on exports in 1991 to that in 1992?
Offer a terse response. 2.18. What is the ratio of the Taxes (in $) of Taxes on goods and services in 1991 to that in 1992?
Keep it short and to the point. 0.69. What is the ratio of the Taxes (in $) of Taxes on income in 1991 to that in 1992?
Make the answer very short. 1.04. What is the ratio of the Taxes (in $) in Taxes on revenue in 1991 to that in 1993?
Offer a very short reply. 0.69. What is the ratio of the Taxes (in $) in Taxes on exports in 1991 to that in 1993?
Provide a short and direct response. 192. What is the ratio of the Taxes (in $) of Taxes on goods and services in 1991 to that in 1993?
Keep it short and to the point. 0.58. What is the ratio of the Taxes (in $) of Taxes on income in 1991 to that in 1993?
Provide a succinct answer. 0.88. What is the ratio of the Taxes (in $) of Taxes on revenue in 1991 to that in 1994?
Give a very brief answer. 0.69. What is the ratio of the Taxes (in $) in Taxes on exports in 1991 to that in 1994?
Your response must be concise. 192. What is the ratio of the Taxes (in $) of Taxes on goods and services in 1991 to that in 1994?
Your answer should be very brief. 0.52. What is the ratio of the Taxes (in $) of Taxes on income in 1991 to that in 1994?
Make the answer very short. 1.23. What is the ratio of the Taxes (in $) of Taxes on revenue in 1991 to that in 1995?
Offer a very short reply. 0.53. What is the ratio of the Taxes (in $) of Taxes on exports in 1991 to that in 1995?
Ensure brevity in your answer.  1.01. What is the ratio of the Taxes (in $) in Taxes on goods and services in 1991 to that in 1995?
Ensure brevity in your answer.  0.44. What is the ratio of the Taxes (in $) in Taxes on income in 1991 to that in 1995?
Keep it short and to the point. 0.76. What is the ratio of the Taxes (in $) in Taxes on revenue in 1991 to that in 1996?
Your answer should be very brief. 0.43. What is the ratio of the Taxes (in $) in Taxes on exports in 1991 to that in 1996?
Your answer should be compact. 0.74. What is the ratio of the Taxes (in $) in Taxes on goods and services in 1991 to that in 1996?
Your answer should be compact. 0.33. What is the ratio of the Taxes (in $) in Taxes on income in 1991 to that in 1996?
Your answer should be very brief. 0.52. What is the ratio of the Taxes (in $) of Taxes on revenue in 1991 to that in 1997?
Keep it short and to the point. 0.37. What is the ratio of the Taxes (in $) in Taxes on exports in 1991 to that in 1997?
Offer a terse response. 1.29. What is the ratio of the Taxes (in $) of Taxes on goods and services in 1991 to that in 1997?
Your answer should be compact. 0.27. What is the ratio of the Taxes (in $) of Taxes on income in 1991 to that in 1997?
Make the answer very short. 0.45. What is the ratio of the Taxes (in $) of Taxes on revenue in 1992 to that in 1993?
Offer a very short reply. 0.89. What is the ratio of the Taxes (in $) in Taxes on goods and services in 1992 to that in 1993?
Offer a terse response. 0.84. What is the ratio of the Taxes (in $) of Taxes on income in 1992 to that in 1993?
Give a very brief answer. 0.84. What is the ratio of the Taxes (in $) in Taxes on revenue in 1992 to that in 1994?
Offer a terse response. 0.89. What is the ratio of the Taxes (in $) in Taxes on goods and services in 1992 to that in 1994?
Your answer should be very brief. 0.76. What is the ratio of the Taxes (in $) of Taxes on income in 1992 to that in 1994?
Provide a succinct answer. 1.18. What is the ratio of the Taxes (in $) in Taxes on revenue in 1992 to that in 1995?
Your answer should be compact. 0.68. What is the ratio of the Taxes (in $) in Taxes on exports in 1992 to that in 1995?
Your response must be concise. 0.46. What is the ratio of the Taxes (in $) in Taxes on goods and services in 1992 to that in 1995?
Offer a very short reply. 0.64. What is the ratio of the Taxes (in $) in Taxes on income in 1992 to that in 1995?
Give a very brief answer. 0.73. What is the ratio of the Taxes (in $) of Taxes on revenue in 1992 to that in 1996?
Offer a very short reply. 0.55. What is the ratio of the Taxes (in $) of Taxes on exports in 1992 to that in 1996?
Keep it short and to the point. 0.34. What is the ratio of the Taxes (in $) in Taxes on goods and services in 1992 to that in 1996?
Offer a very short reply. 0.48. What is the ratio of the Taxes (in $) in Taxes on income in 1992 to that in 1996?
Your answer should be compact. 0.5. What is the ratio of the Taxes (in $) in Taxes on revenue in 1992 to that in 1997?
Give a very brief answer. 0.48. What is the ratio of the Taxes (in $) of Taxes on exports in 1992 to that in 1997?
Provide a short and direct response. 0.59. What is the ratio of the Taxes (in $) of Taxes on goods and services in 1992 to that in 1997?
Provide a short and direct response. 0.39. What is the ratio of the Taxes (in $) of Taxes on income in 1992 to that in 1997?
Provide a short and direct response. 0.43. What is the ratio of the Taxes (in $) of Taxes on goods and services in 1993 to that in 1994?
Provide a succinct answer. 0.9. What is the ratio of the Taxes (in $) in Taxes on income in 1993 to that in 1994?
Your answer should be very brief. 1.4. What is the ratio of the Taxes (in $) of Taxes on revenue in 1993 to that in 1995?
Your answer should be compact. 0.76. What is the ratio of the Taxes (in $) of Taxes on exports in 1993 to that in 1995?
Provide a short and direct response. 0.01. What is the ratio of the Taxes (in $) in Taxes on goods and services in 1993 to that in 1995?
Offer a very short reply. 0.76. What is the ratio of the Taxes (in $) in Taxes on income in 1993 to that in 1995?
Keep it short and to the point. 0.87. What is the ratio of the Taxes (in $) of Taxes on revenue in 1993 to that in 1996?
Make the answer very short. 0.62. What is the ratio of the Taxes (in $) in Taxes on exports in 1993 to that in 1996?
Provide a short and direct response. 0. What is the ratio of the Taxes (in $) in Taxes on goods and services in 1993 to that in 1996?
Make the answer very short. 0.57. What is the ratio of the Taxes (in $) in Taxes on income in 1993 to that in 1996?
Your answer should be compact. 0.59. What is the ratio of the Taxes (in $) in Taxes on revenue in 1993 to that in 1997?
Your answer should be compact. 0.54. What is the ratio of the Taxes (in $) in Taxes on exports in 1993 to that in 1997?
Keep it short and to the point. 0.01. What is the ratio of the Taxes (in $) in Taxes on goods and services in 1993 to that in 1997?
Offer a very short reply. 0.47. What is the ratio of the Taxes (in $) in Taxes on income in 1993 to that in 1997?
Your answer should be compact. 0.51. What is the ratio of the Taxes (in $) of Taxes on revenue in 1994 to that in 1995?
Make the answer very short. 0.77. What is the ratio of the Taxes (in $) in Taxes on exports in 1994 to that in 1995?
Offer a terse response. 0.01. What is the ratio of the Taxes (in $) of Taxes on goods and services in 1994 to that in 1995?
Offer a very short reply. 0.84. What is the ratio of the Taxes (in $) in Taxes on income in 1994 to that in 1995?
Ensure brevity in your answer.  0.62. What is the ratio of the Taxes (in $) of Taxes on revenue in 1994 to that in 1996?
Make the answer very short. 0.62. What is the ratio of the Taxes (in $) in Taxes on exports in 1994 to that in 1996?
Make the answer very short. 0. What is the ratio of the Taxes (in $) in Taxes on goods and services in 1994 to that in 1996?
Your answer should be compact. 0.63. What is the ratio of the Taxes (in $) in Taxes on income in 1994 to that in 1996?
Keep it short and to the point. 0.42. What is the ratio of the Taxes (in $) in Taxes on revenue in 1994 to that in 1997?
Ensure brevity in your answer.  0.54. What is the ratio of the Taxes (in $) in Taxes on exports in 1994 to that in 1997?
Provide a succinct answer. 0.01. What is the ratio of the Taxes (in $) of Taxes on goods and services in 1994 to that in 1997?
Ensure brevity in your answer.  0.52. What is the ratio of the Taxes (in $) in Taxes on income in 1994 to that in 1997?
Your answer should be very brief. 0.37. What is the ratio of the Taxes (in $) of Taxes on revenue in 1995 to that in 1996?
Give a very brief answer. 0.81. What is the ratio of the Taxes (in $) of Taxes on exports in 1995 to that in 1996?
Make the answer very short. 0.73. What is the ratio of the Taxes (in $) in Taxes on goods and services in 1995 to that in 1996?
Make the answer very short. 0.75. What is the ratio of the Taxes (in $) in Taxes on income in 1995 to that in 1996?
Your response must be concise. 0.68. What is the ratio of the Taxes (in $) of Taxes on revenue in 1995 to that in 1997?
Give a very brief answer. 0.7. What is the ratio of the Taxes (in $) of Taxes on exports in 1995 to that in 1997?
Give a very brief answer. 1.28. What is the ratio of the Taxes (in $) in Taxes on goods and services in 1995 to that in 1997?
Give a very brief answer. 0.62. What is the ratio of the Taxes (in $) in Taxes on income in 1995 to that in 1997?
Give a very brief answer. 0.59. What is the ratio of the Taxes (in $) of Taxes on revenue in 1996 to that in 1997?
Your answer should be compact. 0.87. What is the ratio of the Taxes (in $) in Taxes on exports in 1996 to that in 1997?
Make the answer very short. 1.75. What is the ratio of the Taxes (in $) of Taxes on goods and services in 1996 to that in 1997?
Provide a succinct answer. 0.83. What is the ratio of the Taxes (in $) in Taxes on income in 1996 to that in 1997?
Keep it short and to the point. 0.87. What is the difference between the highest and the second highest Taxes (in $) in Taxes on revenue?
Keep it short and to the point. 1.24e+09. What is the difference between the highest and the second highest Taxes (in $) in Taxes on exports?
Keep it short and to the point. 6.90e+05. What is the difference between the highest and the second highest Taxes (in $) of Taxes on goods and services?
Ensure brevity in your answer.  9.36e+08. What is the difference between the highest and the second highest Taxes (in $) in Taxes on income?
Your answer should be very brief. 2.96e+08. What is the difference between the highest and the lowest Taxes (in $) of Taxes on revenue?
Offer a terse response. 5.92e+09. What is the difference between the highest and the lowest Taxes (in $) in Taxes on exports?
Keep it short and to the point. 2.60e+06. What is the difference between the highest and the lowest Taxes (in $) in Taxes on goods and services?
Your answer should be compact. 3.91e+09. What is the difference between the highest and the lowest Taxes (in $) of Taxes on income?
Make the answer very short. 1.45e+09. 